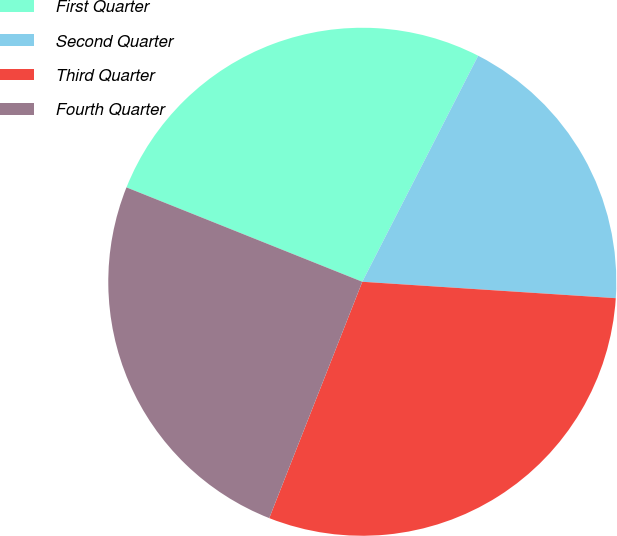Convert chart. <chart><loc_0><loc_0><loc_500><loc_500><pie_chart><fcel>First Quarter<fcel>Second Quarter<fcel>Third Quarter<fcel>Fourth Quarter<nl><fcel>26.48%<fcel>18.49%<fcel>29.94%<fcel>25.09%<nl></chart> 